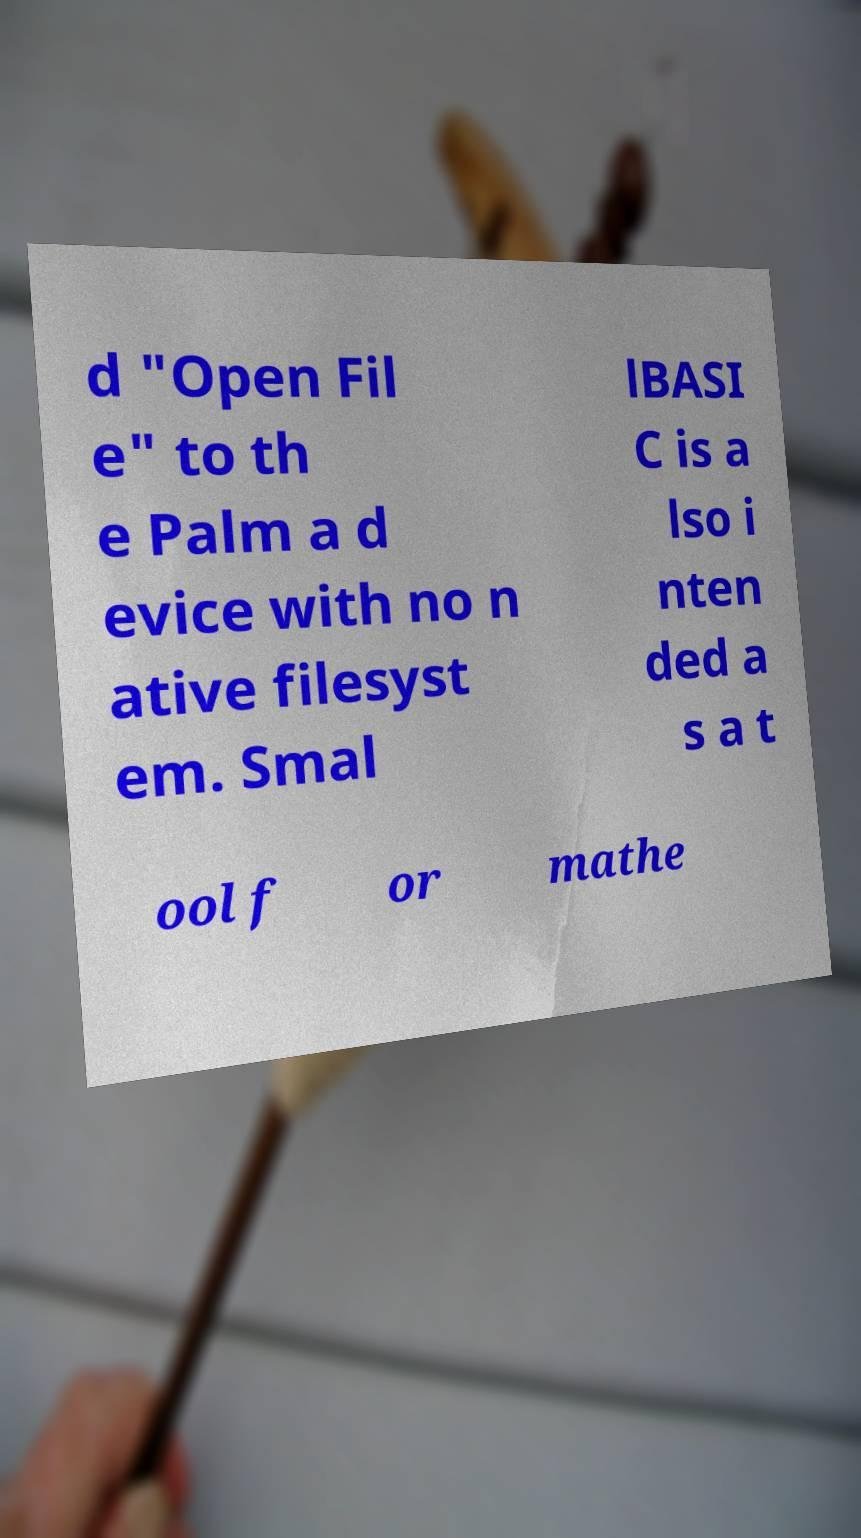What messages or text are displayed in this image? I need them in a readable, typed format. d "Open Fil e" to th e Palm a d evice with no n ative filesyst em. Smal lBASI C is a lso i nten ded a s a t ool f or mathe 